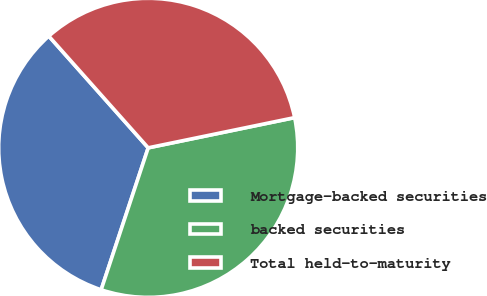Convert chart. <chart><loc_0><loc_0><loc_500><loc_500><pie_chart><fcel>Mortgage-backed securities<fcel>backed securities<fcel>Total held-to-maturity<nl><fcel>33.33%<fcel>33.33%<fcel>33.33%<nl></chart> 